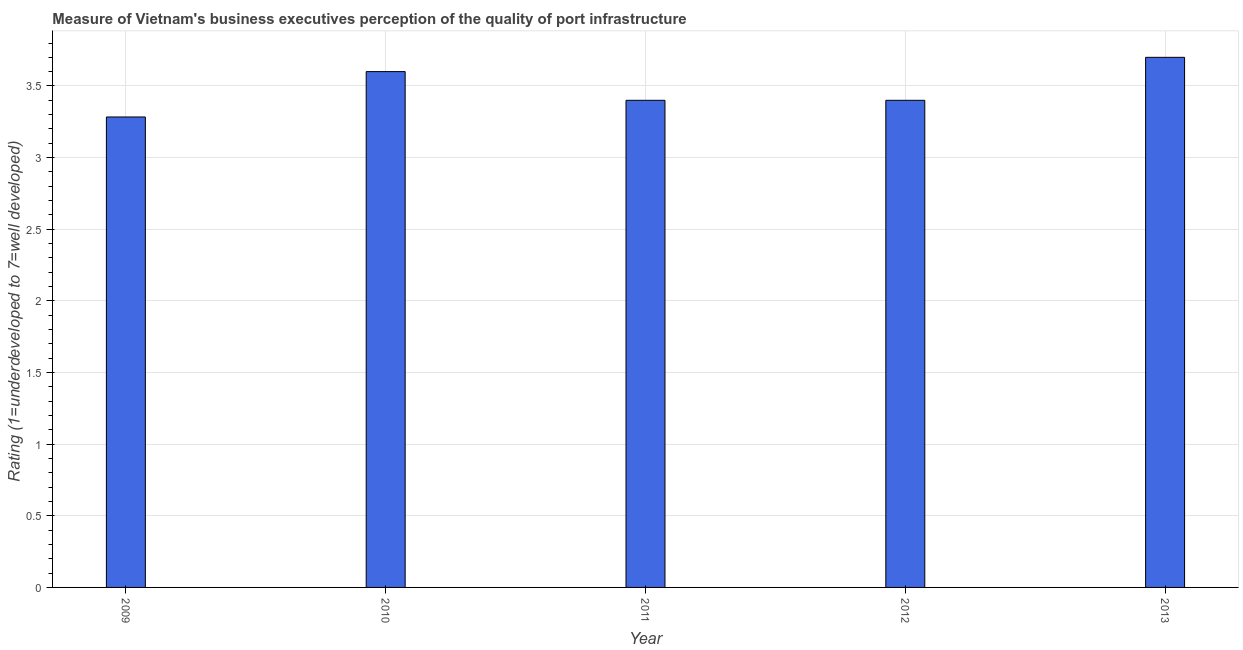Does the graph contain any zero values?
Offer a terse response. No. Does the graph contain grids?
Ensure brevity in your answer.  Yes. What is the title of the graph?
Give a very brief answer. Measure of Vietnam's business executives perception of the quality of port infrastructure. What is the label or title of the Y-axis?
Keep it short and to the point. Rating (1=underdeveloped to 7=well developed) . Across all years, what is the minimum rating measuring quality of port infrastructure?
Offer a terse response. 3.28. In which year was the rating measuring quality of port infrastructure minimum?
Provide a short and direct response. 2009. What is the sum of the rating measuring quality of port infrastructure?
Provide a short and direct response. 17.38. What is the difference between the rating measuring quality of port infrastructure in 2011 and 2012?
Your response must be concise. 0. What is the average rating measuring quality of port infrastructure per year?
Offer a terse response. 3.48. What is the median rating measuring quality of port infrastructure?
Provide a short and direct response. 3.4. What is the ratio of the rating measuring quality of port infrastructure in 2009 to that in 2013?
Offer a very short reply. 0.89. What is the difference between the highest and the lowest rating measuring quality of port infrastructure?
Give a very brief answer. 0.42. In how many years, is the rating measuring quality of port infrastructure greater than the average rating measuring quality of port infrastructure taken over all years?
Provide a succinct answer. 2. Are all the bars in the graph horizontal?
Your response must be concise. No. What is the difference between two consecutive major ticks on the Y-axis?
Ensure brevity in your answer.  0.5. Are the values on the major ticks of Y-axis written in scientific E-notation?
Ensure brevity in your answer.  No. What is the Rating (1=underdeveloped to 7=well developed)  of 2009?
Offer a very short reply. 3.28. What is the Rating (1=underdeveloped to 7=well developed)  of 2010?
Give a very brief answer. 3.6. What is the difference between the Rating (1=underdeveloped to 7=well developed)  in 2009 and 2010?
Keep it short and to the point. -0.32. What is the difference between the Rating (1=underdeveloped to 7=well developed)  in 2009 and 2011?
Make the answer very short. -0.12. What is the difference between the Rating (1=underdeveloped to 7=well developed)  in 2009 and 2012?
Your answer should be compact. -0.12. What is the difference between the Rating (1=underdeveloped to 7=well developed)  in 2009 and 2013?
Make the answer very short. -0.42. What is the difference between the Rating (1=underdeveloped to 7=well developed)  in 2010 and 2011?
Your answer should be very brief. 0.2. What is the difference between the Rating (1=underdeveloped to 7=well developed)  in 2010 and 2012?
Provide a short and direct response. 0.2. What is the difference between the Rating (1=underdeveloped to 7=well developed)  in 2010 and 2013?
Offer a terse response. -0.1. What is the difference between the Rating (1=underdeveloped to 7=well developed)  in 2011 and 2013?
Provide a succinct answer. -0.3. What is the difference between the Rating (1=underdeveloped to 7=well developed)  in 2012 and 2013?
Make the answer very short. -0.3. What is the ratio of the Rating (1=underdeveloped to 7=well developed)  in 2009 to that in 2010?
Make the answer very short. 0.91. What is the ratio of the Rating (1=underdeveloped to 7=well developed)  in 2009 to that in 2012?
Provide a short and direct response. 0.97. What is the ratio of the Rating (1=underdeveloped to 7=well developed)  in 2009 to that in 2013?
Offer a terse response. 0.89. What is the ratio of the Rating (1=underdeveloped to 7=well developed)  in 2010 to that in 2011?
Provide a short and direct response. 1.06. What is the ratio of the Rating (1=underdeveloped to 7=well developed)  in 2010 to that in 2012?
Keep it short and to the point. 1.06. What is the ratio of the Rating (1=underdeveloped to 7=well developed)  in 2010 to that in 2013?
Ensure brevity in your answer.  0.97. What is the ratio of the Rating (1=underdeveloped to 7=well developed)  in 2011 to that in 2012?
Offer a terse response. 1. What is the ratio of the Rating (1=underdeveloped to 7=well developed)  in 2011 to that in 2013?
Give a very brief answer. 0.92. What is the ratio of the Rating (1=underdeveloped to 7=well developed)  in 2012 to that in 2013?
Provide a short and direct response. 0.92. 